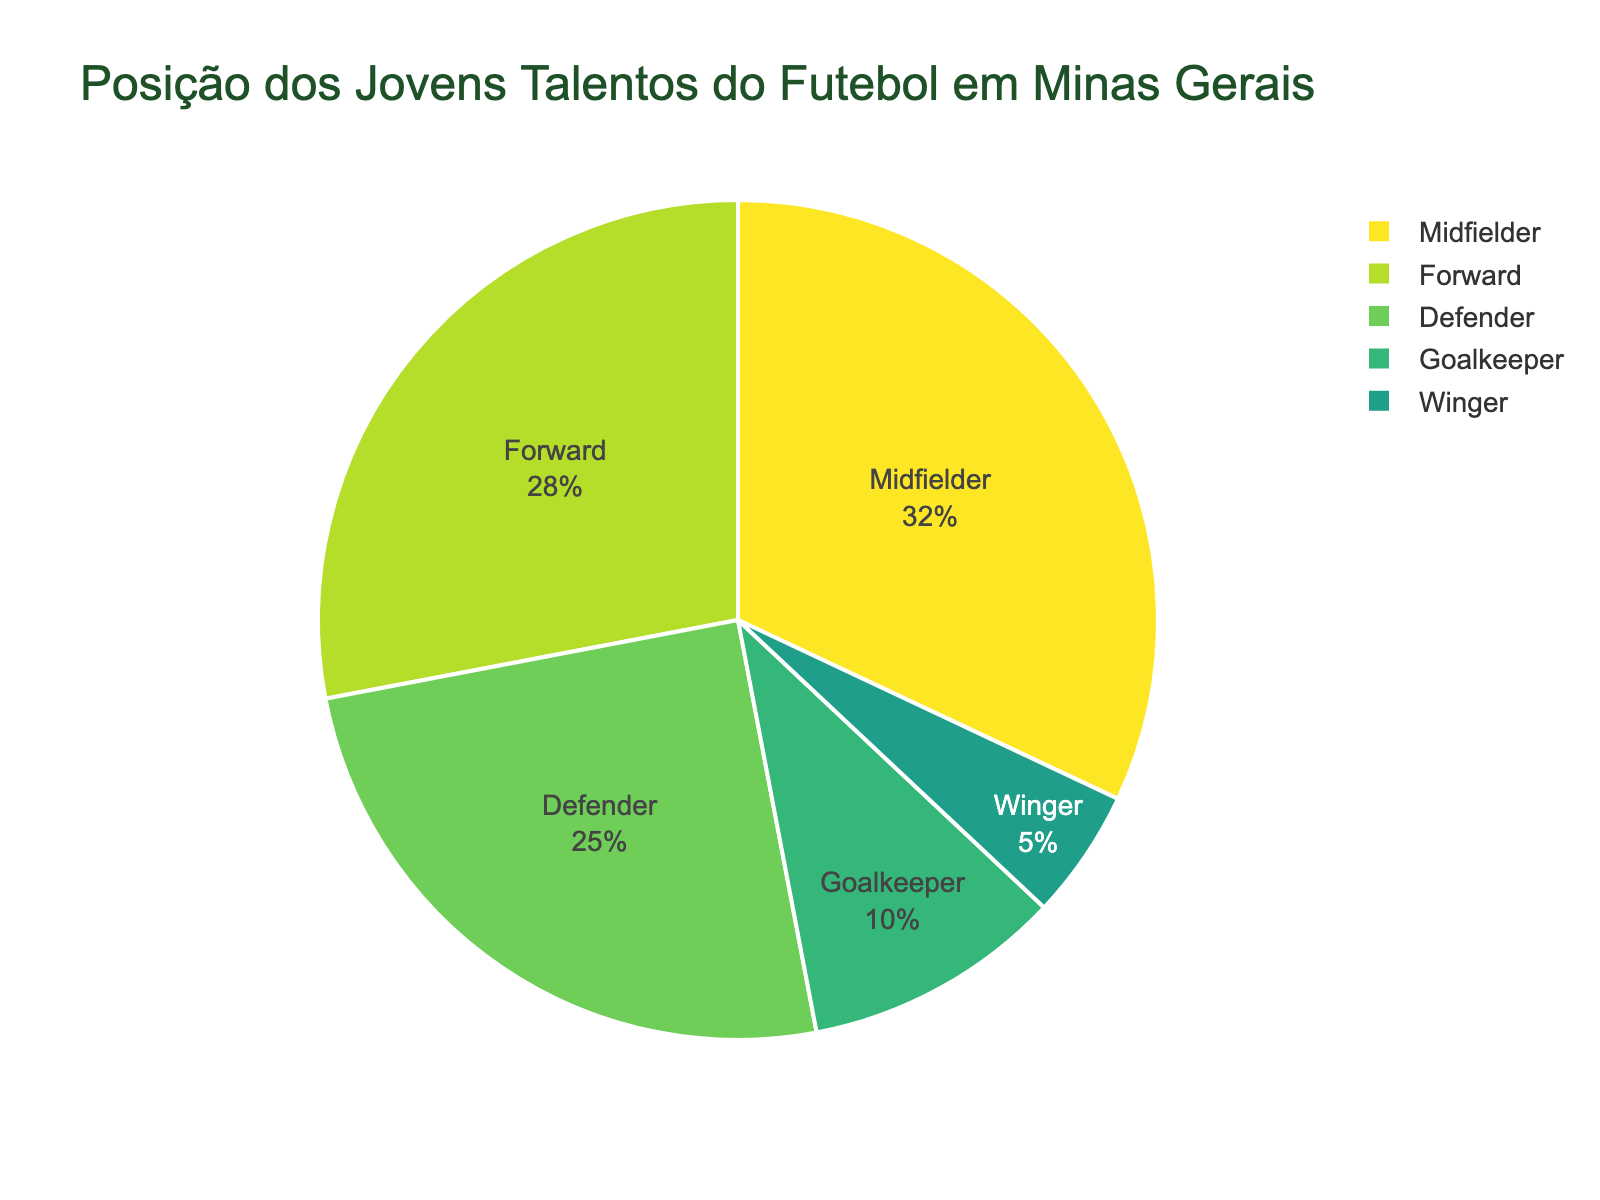What's the most common playing position among local youth soccer talents? To find the most common playing position, look for the largest segment in the pie chart. The segment labeled "Midfielder" has the highest percentage of 32%.
Answer: Midfielder Which playing position has the smallest representation among the local youth soccer talents? Identify the smallest segment in the pie chart. The segment labeled "Winger" has the lowest percentage of 5%.
Answer: Winger What is the combined percentage of Defenders and Goalkeepers among the local youth soccer talents? Add the percentages of the Defenders and Goalkeepers. Defenders have 25% and Goalkeepers have 10%, so the combined percentage is 25% + 10% = 35%.
Answer: 35% How much higher is the percentage of Forwards compared to Wingers among the local youth soccer talents? Subtract the Winger percentage from the Forward percentage. Forwards are 28% and Wingers are 5%, so the difference is 28% - 5% = 23%.
Answer: 23% Which position is more common, Forwards or Defenders, and by how much? Compare the percentages of Forwards and Defenders. Forwards have 28% and Defenders have 25%. Forwards are 28% - 25% = 3% more common than Defenders.
Answer: Forwards, 3% What is the average percentage of Midfielders, Defenders, and Goalkeepers? Add the percentages of Midfielders, Defenders, and Goalkeepers, then divide by 3. Midfielders are 32%, Defenders are 25%, and Goalkeepers are 10%. (32 + 25 + 10) / 3 = 22.33%.
Answer: 22.33% What's the difference in percentage points between the highest and lowest represented playing positions? Subtract the percentage of the lowest represented position (Winger) from the highest represented position (Midfielder). Midfielder is 32% and Winger is 5%, so the difference is 32% - 5% = 27%.
Answer: 27% Among which positions do we notice the biggest percentage drop? Find the positions with the largest percentage gap between them. Comparing all pairs: Midfielders (32%) to Forwards (28%) = 4%; Forwards (28%) to Defenders (25%) = 3%; Defenders (25%) to Goalkeepers (10%) = 15%; Goalkeepers (10%) to Wingers (5%) = 5%. The biggest drop is from Defenders to Goalkeepers, which is 25% - 10% = 15%.
Answer: Defenders to Goalkeepers, 15% What percentage of local youth soccer talents are either Midfielders or Forwards? Sum the percentages of Midfielders and Forwards. Midfielders are 32% and Forwards are 28%. So, 32% + 28% = 60%.
Answer: 60% If another player joins, and they are a Goalkeeper, what will be the new percentage of Goalkeepers, assuming the total number of players was initially 100? Initially, Goalkeepers represent 10% of 100, meaning there are 10 Goalkeepers. Adding one makes 11 Goalkeepers, out of 101 players. The new percentage is (11 / 101) * 100 ≈ 10.89%.
Answer: 10.89% 